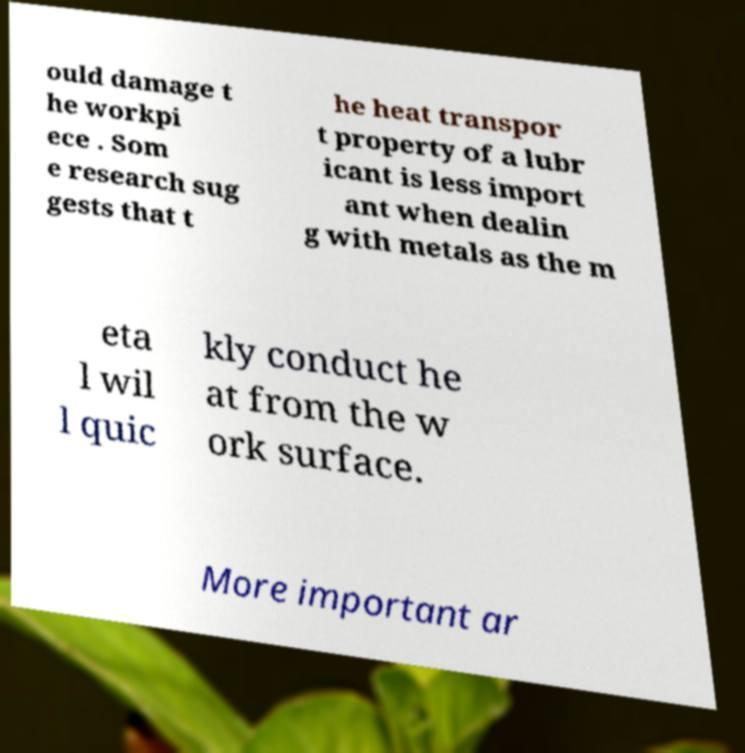Could you extract and type out the text from this image? ould damage t he workpi ece . Som e research sug gests that t he heat transpor t property of a lubr icant is less import ant when dealin g with metals as the m eta l wil l quic kly conduct he at from the w ork surface. More important ar 